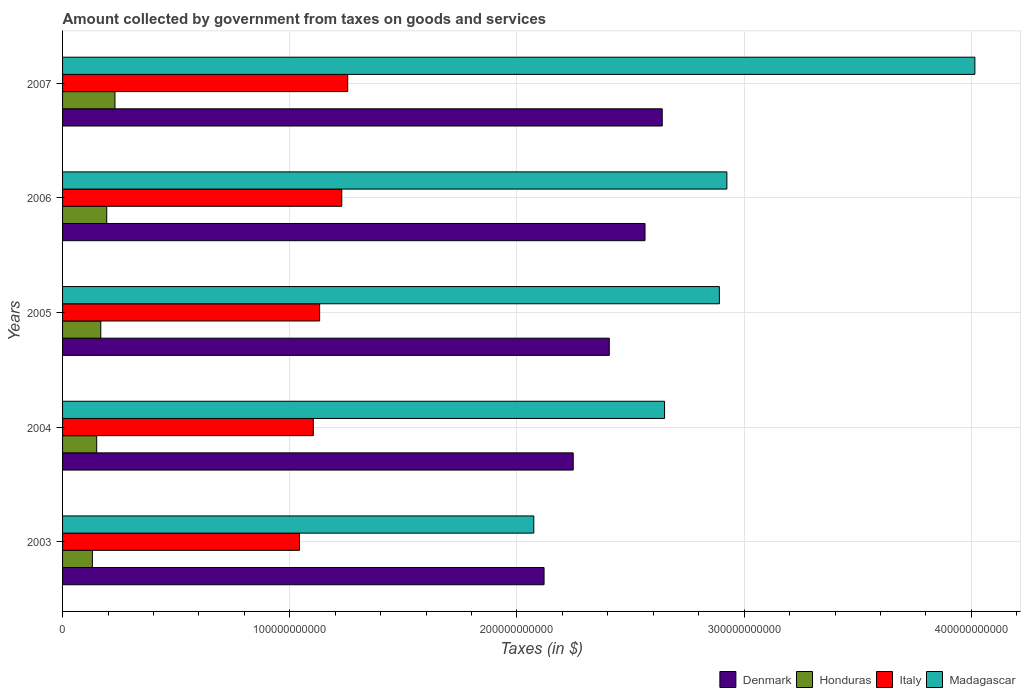How many different coloured bars are there?
Offer a very short reply. 4. How many groups of bars are there?
Ensure brevity in your answer.  5. How many bars are there on the 5th tick from the top?
Ensure brevity in your answer.  4. How many bars are there on the 1st tick from the bottom?
Your response must be concise. 4. In how many cases, is the number of bars for a given year not equal to the number of legend labels?
Ensure brevity in your answer.  0. What is the amount collected by government from taxes on goods and services in Honduras in 2003?
Give a very brief answer. 1.31e+1. Across all years, what is the maximum amount collected by government from taxes on goods and services in Madagascar?
Offer a very short reply. 4.02e+11. Across all years, what is the minimum amount collected by government from taxes on goods and services in Denmark?
Keep it short and to the point. 2.12e+11. In which year was the amount collected by government from taxes on goods and services in Madagascar maximum?
Offer a terse response. 2007. In which year was the amount collected by government from taxes on goods and services in Italy minimum?
Provide a succinct answer. 2003. What is the total amount collected by government from taxes on goods and services in Italy in the graph?
Provide a short and direct response. 5.76e+11. What is the difference between the amount collected by government from taxes on goods and services in Honduras in 2003 and that in 2006?
Keep it short and to the point. -6.32e+09. What is the difference between the amount collected by government from taxes on goods and services in Madagascar in 2006 and the amount collected by government from taxes on goods and services in Denmark in 2005?
Offer a terse response. 5.18e+1. What is the average amount collected by government from taxes on goods and services in Madagascar per year?
Offer a very short reply. 2.91e+11. In the year 2004, what is the difference between the amount collected by government from taxes on goods and services in Italy and amount collected by government from taxes on goods and services in Honduras?
Make the answer very short. 9.53e+1. In how many years, is the amount collected by government from taxes on goods and services in Madagascar greater than 340000000000 $?
Your response must be concise. 1. What is the ratio of the amount collected by government from taxes on goods and services in Honduras in 2006 to that in 2007?
Provide a succinct answer. 0.84. Is the difference between the amount collected by government from taxes on goods and services in Italy in 2003 and 2006 greater than the difference between the amount collected by government from taxes on goods and services in Honduras in 2003 and 2006?
Your response must be concise. No. What is the difference between the highest and the second highest amount collected by government from taxes on goods and services in Honduras?
Make the answer very short. 3.63e+09. What is the difference between the highest and the lowest amount collected by government from taxes on goods and services in Honduras?
Offer a very short reply. 9.94e+09. In how many years, is the amount collected by government from taxes on goods and services in Denmark greater than the average amount collected by government from taxes on goods and services in Denmark taken over all years?
Offer a terse response. 3. Is it the case that in every year, the sum of the amount collected by government from taxes on goods and services in Honduras and amount collected by government from taxes on goods and services in Denmark is greater than the sum of amount collected by government from taxes on goods and services in Madagascar and amount collected by government from taxes on goods and services in Italy?
Provide a succinct answer. Yes. What does the 1st bar from the top in 2003 represents?
Your answer should be compact. Madagascar. What does the 1st bar from the bottom in 2007 represents?
Offer a very short reply. Denmark. Are all the bars in the graph horizontal?
Keep it short and to the point. Yes. What is the difference between two consecutive major ticks on the X-axis?
Provide a succinct answer. 1.00e+11. Are the values on the major ticks of X-axis written in scientific E-notation?
Your answer should be very brief. No. Does the graph contain any zero values?
Provide a succinct answer. No. How are the legend labels stacked?
Keep it short and to the point. Horizontal. What is the title of the graph?
Keep it short and to the point. Amount collected by government from taxes on goods and services. Does "Samoa" appear as one of the legend labels in the graph?
Your answer should be compact. No. What is the label or title of the X-axis?
Your response must be concise. Taxes (in $). What is the label or title of the Y-axis?
Ensure brevity in your answer.  Years. What is the Taxes (in $) of Denmark in 2003?
Offer a very short reply. 2.12e+11. What is the Taxes (in $) in Honduras in 2003?
Ensure brevity in your answer.  1.31e+1. What is the Taxes (in $) in Italy in 2003?
Keep it short and to the point. 1.04e+11. What is the Taxes (in $) in Madagascar in 2003?
Your answer should be compact. 2.07e+11. What is the Taxes (in $) of Denmark in 2004?
Provide a short and direct response. 2.25e+11. What is the Taxes (in $) of Honduras in 2004?
Give a very brief answer. 1.50e+1. What is the Taxes (in $) in Italy in 2004?
Offer a very short reply. 1.10e+11. What is the Taxes (in $) in Madagascar in 2004?
Provide a succinct answer. 2.65e+11. What is the Taxes (in $) of Denmark in 2005?
Make the answer very short. 2.41e+11. What is the Taxes (in $) of Honduras in 2005?
Offer a very short reply. 1.68e+1. What is the Taxes (in $) of Italy in 2005?
Make the answer very short. 1.13e+11. What is the Taxes (in $) of Madagascar in 2005?
Offer a very short reply. 2.89e+11. What is the Taxes (in $) of Denmark in 2006?
Offer a very short reply. 2.56e+11. What is the Taxes (in $) in Honduras in 2006?
Your answer should be very brief. 1.94e+1. What is the Taxes (in $) in Italy in 2006?
Give a very brief answer. 1.23e+11. What is the Taxes (in $) of Madagascar in 2006?
Keep it short and to the point. 2.92e+11. What is the Taxes (in $) in Denmark in 2007?
Provide a succinct answer. 2.64e+11. What is the Taxes (in $) in Honduras in 2007?
Your response must be concise. 2.31e+1. What is the Taxes (in $) in Italy in 2007?
Ensure brevity in your answer.  1.26e+11. What is the Taxes (in $) in Madagascar in 2007?
Your answer should be compact. 4.02e+11. Across all years, what is the maximum Taxes (in $) of Denmark?
Offer a very short reply. 2.64e+11. Across all years, what is the maximum Taxes (in $) in Honduras?
Your response must be concise. 2.31e+1. Across all years, what is the maximum Taxes (in $) of Italy?
Give a very brief answer. 1.26e+11. Across all years, what is the maximum Taxes (in $) in Madagascar?
Provide a short and direct response. 4.02e+11. Across all years, what is the minimum Taxes (in $) of Denmark?
Provide a short and direct response. 2.12e+11. Across all years, what is the minimum Taxes (in $) in Honduras?
Provide a succinct answer. 1.31e+1. Across all years, what is the minimum Taxes (in $) of Italy?
Keep it short and to the point. 1.04e+11. Across all years, what is the minimum Taxes (in $) of Madagascar?
Provide a succinct answer. 2.07e+11. What is the total Taxes (in $) in Denmark in the graph?
Keep it short and to the point. 1.20e+12. What is the total Taxes (in $) of Honduras in the graph?
Keep it short and to the point. 8.75e+1. What is the total Taxes (in $) in Italy in the graph?
Make the answer very short. 5.76e+11. What is the total Taxes (in $) in Madagascar in the graph?
Offer a very short reply. 1.46e+12. What is the difference between the Taxes (in $) of Denmark in 2003 and that in 2004?
Provide a short and direct response. -1.28e+1. What is the difference between the Taxes (in $) in Honduras in 2003 and that in 2004?
Your answer should be very brief. -1.90e+09. What is the difference between the Taxes (in $) of Italy in 2003 and that in 2004?
Provide a succinct answer. -6.08e+09. What is the difference between the Taxes (in $) in Madagascar in 2003 and that in 2004?
Provide a succinct answer. -5.76e+1. What is the difference between the Taxes (in $) of Denmark in 2003 and that in 2005?
Your answer should be very brief. -2.87e+1. What is the difference between the Taxes (in $) in Honduras in 2003 and that in 2005?
Provide a succinct answer. -3.70e+09. What is the difference between the Taxes (in $) of Italy in 2003 and that in 2005?
Your response must be concise. -8.87e+09. What is the difference between the Taxes (in $) of Madagascar in 2003 and that in 2005?
Provide a short and direct response. -8.17e+1. What is the difference between the Taxes (in $) in Denmark in 2003 and that in 2006?
Give a very brief answer. -4.44e+1. What is the difference between the Taxes (in $) of Honduras in 2003 and that in 2006?
Provide a succinct answer. -6.32e+09. What is the difference between the Taxes (in $) in Italy in 2003 and that in 2006?
Keep it short and to the point. -1.86e+1. What is the difference between the Taxes (in $) of Madagascar in 2003 and that in 2006?
Offer a terse response. -8.50e+1. What is the difference between the Taxes (in $) in Denmark in 2003 and that in 2007?
Give a very brief answer. -5.20e+1. What is the difference between the Taxes (in $) in Honduras in 2003 and that in 2007?
Your answer should be compact. -9.94e+09. What is the difference between the Taxes (in $) in Italy in 2003 and that in 2007?
Give a very brief answer. -2.12e+1. What is the difference between the Taxes (in $) in Madagascar in 2003 and that in 2007?
Your answer should be compact. -1.94e+11. What is the difference between the Taxes (in $) of Denmark in 2004 and that in 2005?
Give a very brief answer. -1.59e+1. What is the difference between the Taxes (in $) of Honduras in 2004 and that in 2005?
Provide a short and direct response. -1.80e+09. What is the difference between the Taxes (in $) in Italy in 2004 and that in 2005?
Provide a succinct answer. -2.78e+09. What is the difference between the Taxes (in $) of Madagascar in 2004 and that in 2005?
Your answer should be compact. -2.41e+1. What is the difference between the Taxes (in $) in Denmark in 2004 and that in 2006?
Your answer should be compact. -3.16e+1. What is the difference between the Taxes (in $) in Honduras in 2004 and that in 2006?
Provide a short and direct response. -4.42e+09. What is the difference between the Taxes (in $) of Italy in 2004 and that in 2006?
Provide a short and direct response. -1.25e+1. What is the difference between the Taxes (in $) in Madagascar in 2004 and that in 2006?
Provide a succinct answer. -2.74e+1. What is the difference between the Taxes (in $) of Denmark in 2004 and that in 2007?
Give a very brief answer. -3.92e+1. What is the difference between the Taxes (in $) in Honduras in 2004 and that in 2007?
Your response must be concise. -8.05e+09. What is the difference between the Taxes (in $) of Italy in 2004 and that in 2007?
Ensure brevity in your answer.  -1.51e+1. What is the difference between the Taxes (in $) in Madagascar in 2004 and that in 2007?
Provide a short and direct response. -1.37e+11. What is the difference between the Taxes (in $) in Denmark in 2005 and that in 2006?
Keep it short and to the point. -1.57e+1. What is the difference between the Taxes (in $) in Honduras in 2005 and that in 2006?
Your answer should be very brief. -2.62e+09. What is the difference between the Taxes (in $) in Italy in 2005 and that in 2006?
Ensure brevity in your answer.  -9.75e+09. What is the difference between the Taxes (in $) of Madagascar in 2005 and that in 2006?
Offer a terse response. -3.30e+09. What is the difference between the Taxes (in $) of Denmark in 2005 and that in 2007?
Offer a very short reply. -2.33e+1. What is the difference between the Taxes (in $) in Honduras in 2005 and that in 2007?
Give a very brief answer. -6.25e+09. What is the difference between the Taxes (in $) in Italy in 2005 and that in 2007?
Your answer should be very brief. -1.24e+1. What is the difference between the Taxes (in $) of Madagascar in 2005 and that in 2007?
Offer a terse response. -1.12e+11. What is the difference between the Taxes (in $) of Denmark in 2006 and that in 2007?
Keep it short and to the point. -7.58e+09. What is the difference between the Taxes (in $) of Honduras in 2006 and that in 2007?
Ensure brevity in your answer.  -3.63e+09. What is the difference between the Taxes (in $) of Italy in 2006 and that in 2007?
Your answer should be very brief. -2.61e+09. What is the difference between the Taxes (in $) of Madagascar in 2006 and that in 2007?
Offer a very short reply. -1.09e+11. What is the difference between the Taxes (in $) in Denmark in 2003 and the Taxes (in $) in Honduras in 2004?
Make the answer very short. 1.97e+11. What is the difference between the Taxes (in $) of Denmark in 2003 and the Taxes (in $) of Italy in 2004?
Your answer should be very brief. 1.02e+11. What is the difference between the Taxes (in $) in Denmark in 2003 and the Taxes (in $) in Madagascar in 2004?
Your response must be concise. -5.30e+1. What is the difference between the Taxes (in $) of Honduras in 2003 and the Taxes (in $) of Italy in 2004?
Provide a short and direct response. -9.72e+1. What is the difference between the Taxes (in $) in Honduras in 2003 and the Taxes (in $) in Madagascar in 2004?
Give a very brief answer. -2.52e+11. What is the difference between the Taxes (in $) in Italy in 2003 and the Taxes (in $) in Madagascar in 2004?
Provide a short and direct response. -1.61e+11. What is the difference between the Taxes (in $) in Denmark in 2003 and the Taxes (in $) in Honduras in 2005?
Provide a succinct answer. 1.95e+11. What is the difference between the Taxes (in $) in Denmark in 2003 and the Taxes (in $) in Italy in 2005?
Give a very brief answer. 9.88e+1. What is the difference between the Taxes (in $) in Denmark in 2003 and the Taxes (in $) in Madagascar in 2005?
Ensure brevity in your answer.  -7.72e+1. What is the difference between the Taxes (in $) of Honduras in 2003 and the Taxes (in $) of Italy in 2005?
Keep it short and to the point. -1.00e+11. What is the difference between the Taxes (in $) in Honduras in 2003 and the Taxes (in $) in Madagascar in 2005?
Offer a very short reply. -2.76e+11. What is the difference between the Taxes (in $) of Italy in 2003 and the Taxes (in $) of Madagascar in 2005?
Your response must be concise. -1.85e+11. What is the difference between the Taxes (in $) in Denmark in 2003 and the Taxes (in $) in Honduras in 2006?
Provide a short and direct response. 1.92e+11. What is the difference between the Taxes (in $) in Denmark in 2003 and the Taxes (in $) in Italy in 2006?
Your answer should be very brief. 8.90e+1. What is the difference between the Taxes (in $) of Denmark in 2003 and the Taxes (in $) of Madagascar in 2006?
Offer a very short reply. -8.05e+1. What is the difference between the Taxes (in $) of Honduras in 2003 and the Taxes (in $) of Italy in 2006?
Your response must be concise. -1.10e+11. What is the difference between the Taxes (in $) in Honduras in 2003 and the Taxes (in $) in Madagascar in 2006?
Make the answer very short. -2.79e+11. What is the difference between the Taxes (in $) of Italy in 2003 and the Taxes (in $) of Madagascar in 2006?
Ensure brevity in your answer.  -1.88e+11. What is the difference between the Taxes (in $) of Denmark in 2003 and the Taxes (in $) of Honduras in 2007?
Make the answer very short. 1.89e+11. What is the difference between the Taxes (in $) of Denmark in 2003 and the Taxes (in $) of Italy in 2007?
Provide a succinct answer. 8.64e+1. What is the difference between the Taxes (in $) of Denmark in 2003 and the Taxes (in $) of Madagascar in 2007?
Offer a very short reply. -1.90e+11. What is the difference between the Taxes (in $) of Honduras in 2003 and the Taxes (in $) of Italy in 2007?
Make the answer very short. -1.12e+11. What is the difference between the Taxes (in $) of Honduras in 2003 and the Taxes (in $) of Madagascar in 2007?
Keep it short and to the point. -3.88e+11. What is the difference between the Taxes (in $) in Italy in 2003 and the Taxes (in $) in Madagascar in 2007?
Ensure brevity in your answer.  -2.97e+11. What is the difference between the Taxes (in $) in Denmark in 2004 and the Taxes (in $) in Honduras in 2005?
Your response must be concise. 2.08e+11. What is the difference between the Taxes (in $) of Denmark in 2004 and the Taxes (in $) of Italy in 2005?
Give a very brief answer. 1.12e+11. What is the difference between the Taxes (in $) in Denmark in 2004 and the Taxes (in $) in Madagascar in 2005?
Keep it short and to the point. -6.43e+1. What is the difference between the Taxes (in $) of Honduras in 2004 and the Taxes (in $) of Italy in 2005?
Offer a very short reply. -9.81e+1. What is the difference between the Taxes (in $) in Honduras in 2004 and the Taxes (in $) in Madagascar in 2005?
Provide a succinct answer. -2.74e+11. What is the difference between the Taxes (in $) in Italy in 2004 and the Taxes (in $) in Madagascar in 2005?
Your response must be concise. -1.79e+11. What is the difference between the Taxes (in $) of Denmark in 2004 and the Taxes (in $) of Honduras in 2006?
Provide a succinct answer. 2.05e+11. What is the difference between the Taxes (in $) in Denmark in 2004 and the Taxes (in $) in Italy in 2006?
Your response must be concise. 1.02e+11. What is the difference between the Taxes (in $) in Denmark in 2004 and the Taxes (in $) in Madagascar in 2006?
Your answer should be compact. -6.76e+1. What is the difference between the Taxes (in $) of Honduras in 2004 and the Taxes (in $) of Italy in 2006?
Your response must be concise. -1.08e+11. What is the difference between the Taxes (in $) of Honduras in 2004 and the Taxes (in $) of Madagascar in 2006?
Offer a very short reply. -2.77e+11. What is the difference between the Taxes (in $) in Italy in 2004 and the Taxes (in $) in Madagascar in 2006?
Give a very brief answer. -1.82e+11. What is the difference between the Taxes (in $) of Denmark in 2004 and the Taxes (in $) of Honduras in 2007?
Make the answer very short. 2.02e+11. What is the difference between the Taxes (in $) in Denmark in 2004 and the Taxes (in $) in Italy in 2007?
Provide a short and direct response. 9.93e+1. What is the difference between the Taxes (in $) in Denmark in 2004 and the Taxes (in $) in Madagascar in 2007?
Make the answer very short. -1.77e+11. What is the difference between the Taxes (in $) of Honduras in 2004 and the Taxes (in $) of Italy in 2007?
Your response must be concise. -1.10e+11. What is the difference between the Taxes (in $) in Honduras in 2004 and the Taxes (in $) in Madagascar in 2007?
Ensure brevity in your answer.  -3.87e+11. What is the difference between the Taxes (in $) in Italy in 2004 and the Taxes (in $) in Madagascar in 2007?
Ensure brevity in your answer.  -2.91e+11. What is the difference between the Taxes (in $) of Denmark in 2005 and the Taxes (in $) of Honduras in 2006?
Provide a short and direct response. 2.21e+11. What is the difference between the Taxes (in $) of Denmark in 2005 and the Taxes (in $) of Italy in 2006?
Offer a terse response. 1.18e+11. What is the difference between the Taxes (in $) of Denmark in 2005 and the Taxes (in $) of Madagascar in 2006?
Offer a terse response. -5.18e+1. What is the difference between the Taxes (in $) of Honduras in 2005 and the Taxes (in $) of Italy in 2006?
Ensure brevity in your answer.  -1.06e+11. What is the difference between the Taxes (in $) of Honduras in 2005 and the Taxes (in $) of Madagascar in 2006?
Provide a short and direct response. -2.76e+11. What is the difference between the Taxes (in $) of Italy in 2005 and the Taxes (in $) of Madagascar in 2006?
Keep it short and to the point. -1.79e+11. What is the difference between the Taxes (in $) of Denmark in 2005 and the Taxes (in $) of Honduras in 2007?
Give a very brief answer. 2.18e+11. What is the difference between the Taxes (in $) in Denmark in 2005 and the Taxes (in $) in Italy in 2007?
Keep it short and to the point. 1.15e+11. What is the difference between the Taxes (in $) in Denmark in 2005 and the Taxes (in $) in Madagascar in 2007?
Give a very brief answer. -1.61e+11. What is the difference between the Taxes (in $) of Honduras in 2005 and the Taxes (in $) of Italy in 2007?
Provide a short and direct response. -1.09e+11. What is the difference between the Taxes (in $) of Honduras in 2005 and the Taxes (in $) of Madagascar in 2007?
Your response must be concise. -3.85e+11. What is the difference between the Taxes (in $) of Italy in 2005 and the Taxes (in $) of Madagascar in 2007?
Your answer should be very brief. -2.88e+11. What is the difference between the Taxes (in $) of Denmark in 2006 and the Taxes (in $) of Honduras in 2007?
Your answer should be compact. 2.33e+11. What is the difference between the Taxes (in $) of Denmark in 2006 and the Taxes (in $) of Italy in 2007?
Provide a short and direct response. 1.31e+11. What is the difference between the Taxes (in $) of Denmark in 2006 and the Taxes (in $) of Madagascar in 2007?
Offer a very short reply. -1.45e+11. What is the difference between the Taxes (in $) in Honduras in 2006 and the Taxes (in $) in Italy in 2007?
Your answer should be compact. -1.06e+11. What is the difference between the Taxes (in $) in Honduras in 2006 and the Taxes (in $) in Madagascar in 2007?
Ensure brevity in your answer.  -3.82e+11. What is the difference between the Taxes (in $) of Italy in 2006 and the Taxes (in $) of Madagascar in 2007?
Make the answer very short. -2.79e+11. What is the average Taxes (in $) in Denmark per year?
Keep it short and to the point. 2.40e+11. What is the average Taxes (in $) of Honduras per year?
Provide a short and direct response. 1.75e+1. What is the average Taxes (in $) of Italy per year?
Keep it short and to the point. 1.15e+11. What is the average Taxes (in $) in Madagascar per year?
Give a very brief answer. 2.91e+11. In the year 2003, what is the difference between the Taxes (in $) in Denmark and Taxes (in $) in Honduras?
Offer a very short reply. 1.99e+11. In the year 2003, what is the difference between the Taxes (in $) in Denmark and Taxes (in $) in Italy?
Provide a succinct answer. 1.08e+11. In the year 2003, what is the difference between the Taxes (in $) in Denmark and Taxes (in $) in Madagascar?
Provide a succinct answer. 4.53e+09. In the year 2003, what is the difference between the Taxes (in $) in Honduras and Taxes (in $) in Italy?
Give a very brief answer. -9.12e+1. In the year 2003, what is the difference between the Taxes (in $) of Honduras and Taxes (in $) of Madagascar?
Offer a very short reply. -1.94e+11. In the year 2003, what is the difference between the Taxes (in $) in Italy and Taxes (in $) in Madagascar?
Keep it short and to the point. -1.03e+11. In the year 2004, what is the difference between the Taxes (in $) in Denmark and Taxes (in $) in Honduras?
Make the answer very short. 2.10e+11. In the year 2004, what is the difference between the Taxes (in $) of Denmark and Taxes (in $) of Italy?
Offer a terse response. 1.14e+11. In the year 2004, what is the difference between the Taxes (in $) in Denmark and Taxes (in $) in Madagascar?
Make the answer very short. -4.02e+1. In the year 2004, what is the difference between the Taxes (in $) of Honduras and Taxes (in $) of Italy?
Ensure brevity in your answer.  -9.53e+1. In the year 2004, what is the difference between the Taxes (in $) of Honduras and Taxes (in $) of Madagascar?
Your response must be concise. -2.50e+11. In the year 2004, what is the difference between the Taxes (in $) in Italy and Taxes (in $) in Madagascar?
Your answer should be very brief. -1.55e+11. In the year 2005, what is the difference between the Taxes (in $) of Denmark and Taxes (in $) of Honduras?
Your answer should be compact. 2.24e+11. In the year 2005, what is the difference between the Taxes (in $) in Denmark and Taxes (in $) in Italy?
Your answer should be very brief. 1.27e+11. In the year 2005, what is the difference between the Taxes (in $) of Denmark and Taxes (in $) of Madagascar?
Your answer should be compact. -4.85e+1. In the year 2005, what is the difference between the Taxes (in $) in Honduras and Taxes (in $) in Italy?
Ensure brevity in your answer.  -9.63e+1. In the year 2005, what is the difference between the Taxes (in $) of Honduras and Taxes (in $) of Madagascar?
Make the answer very short. -2.72e+11. In the year 2005, what is the difference between the Taxes (in $) of Italy and Taxes (in $) of Madagascar?
Provide a short and direct response. -1.76e+11. In the year 2006, what is the difference between the Taxes (in $) of Denmark and Taxes (in $) of Honduras?
Provide a succinct answer. 2.37e+11. In the year 2006, what is the difference between the Taxes (in $) of Denmark and Taxes (in $) of Italy?
Offer a very short reply. 1.33e+11. In the year 2006, what is the difference between the Taxes (in $) of Denmark and Taxes (in $) of Madagascar?
Make the answer very short. -3.60e+1. In the year 2006, what is the difference between the Taxes (in $) in Honduras and Taxes (in $) in Italy?
Provide a succinct answer. -1.03e+11. In the year 2006, what is the difference between the Taxes (in $) of Honduras and Taxes (in $) of Madagascar?
Provide a succinct answer. -2.73e+11. In the year 2006, what is the difference between the Taxes (in $) in Italy and Taxes (in $) in Madagascar?
Offer a very short reply. -1.70e+11. In the year 2007, what is the difference between the Taxes (in $) of Denmark and Taxes (in $) of Honduras?
Give a very brief answer. 2.41e+11. In the year 2007, what is the difference between the Taxes (in $) of Denmark and Taxes (in $) of Italy?
Provide a short and direct response. 1.38e+11. In the year 2007, what is the difference between the Taxes (in $) of Denmark and Taxes (in $) of Madagascar?
Offer a terse response. -1.38e+11. In the year 2007, what is the difference between the Taxes (in $) in Honduras and Taxes (in $) in Italy?
Provide a succinct answer. -1.02e+11. In the year 2007, what is the difference between the Taxes (in $) in Honduras and Taxes (in $) in Madagascar?
Offer a very short reply. -3.78e+11. In the year 2007, what is the difference between the Taxes (in $) of Italy and Taxes (in $) of Madagascar?
Give a very brief answer. -2.76e+11. What is the ratio of the Taxes (in $) in Denmark in 2003 to that in 2004?
Make the answer very short. 0.94. What is the ratio of the Taxes (in $) of Honduras in 2003 to that in 2004?
Your answer should be very brief. 0.87. What is the ratio of the Taxes (in $) of Italy in 2003 to that in 2004?
Offer a terse response. 0.94. What is the ratio of the Taxes (in $) in Madagascar in 2003 to that in 2004?
Make the answer very short. 0.78. What is the ratio of the Taxes (in $) of Denmark in 2003 to that in 2005?
Keep it short and to the point. 0.88. What is the ratio of the Taxes (in $) of Honduras in 2003 to that in 2005?
Make the answer very short. 0.78. What is the ratio of the Taxes (in $) of Italy in 2003 to that in 2005?
Your response must be concise. 0.92. What is the ratio of the Taxes (in $) in Madagascar in 2003 to that in 2005?
Your response must be concise. 0.72. What is the ratio of the Taxes (in $) of Denmark in 2003 to that in 2006?
Make the answer very short. 0.83. What is the ratio of the Taxes (in $) in Honduras in 2003 to that in 2006?
Your response must be concise. 0.68. What is the ratio of the Taxes (in $) in Italy in 2003 to that in 2006?
Give a very brief answer. 0.85. What is the ratio of the Taxes (in $) in Madagascar in 2003 to that in 2006?
Ensure brevity in your answer.  0.71. What is the ratio of the Taxes (in $) in Denmark in 2003 to that in 2007?
Provide a short and direct response. 0.8. What is the ratio of the Taxes (in $) in Honduras in 2003 to that in 2007?
Give a very brief answer. 0.57. What is the ratio of the Taxes (in $) of Italy in 2003 to that in 2007?
Make the answer very short. 0.83. What is the ratio of the Taxes (in $) in Madagascar in 2003 to that in 2007?
Keep it short and to the point. 0.52. What is the ratio of the Taxes (in $) of Denmark in 2004 to that in 2005?
Give a very brief answer. 0.93. What is the ratio of the Taxes (in $) in Honduras in 2004 to that in 2005?
Give a very brief answer. 0.89. What is the ratio of the Taxes (in $) of Italy in 2004 to that in 2005?
Make the answer very short. 0.98. What is the ratio of the Taxes (in $) in Madagascar in 2004 to that in 2005?
Your answer should be very brief. 0.92. What is the ratio of the Taxes (in $) of Denmark in 2004 to that in 2006?
Your answer should be compact. 0.88. What is the ratio of the Taxes (in $) in Honduras in 2004 to that in 2006?
Your answer should be compact. 0.77. What is the ratio of the Taxes (in $) in Italy in 2004 to that in 2006?
Give a very brief answer. 0.9. What is the ratio of the Taxes (in $) of Madagascar in 2004 to that in 2006?
Your answer should be very brief. 0.91. What is the ratio of the Taxes (in $) in Denmark in 2004 to that in 2007?
Provide a short and direct response. 0.85. What is the ratio of the Taxes (in $) in Honduras in 2004 to that in 2007?
Provide a succinct answer. 0.65. What is the ratio of the Taxes (in $) of Italy in 2004 to that in 2007?
Your response must be concise. 0.88. What is the ratio of the Taxes (in $) of Madagascar in 2004 to that in 2007?
Your answer should be compact. 0.66. What is the ratio of the Taxes (in $) in Denmark in 2005 to that in 2006?
Provide a short and direct response. 0.94. What is the ratio of the Taxes (in $) in Honduras in 2005 to that in 2006?
Keep it short and to the point. 0.87. What is the ratio of the Taxes (in $) of Italy in 2005 to that in 2006?
Your answer should be very brief. 0.92. What is the ratio of the Taxes (in $) of Madagascar in 2005 to that in 2006?
Keep it short and to the point. 0.99. What is the ratio of the Taxes (in $) in Denmark in 2005 to that in 2007?
Ensure brevity in your answer.  0.91. What is the ratio of the Taxes (in $) in Honduras in 2005 to that in 2007?
Your answer should be very brief. 0.73. What is the ratio of the Taxes (in $) in Italy in 2005 to that in 2007?
Keep it short and to the point. 0.9. What is the ratio of the Taxes (in $) of Madagascar in 2005 to that in 2007?
Keep it short and to the point. 0.72. What is the ratio of the Taxes (in $) in Denmark in 2006 to that in 2007?
Make the answer very short. 0.97. What is the ratio of the Taxes (in $) of Honduras in 2006 to that in 2007?
Your answer should be very brief. 0.84. What is the ratio of the Taxes (in $) in Italy in 2006 to that in 2007?
Give a very brief answer. 0.98. What is the ratio of the Taxes (in $) in Madagascar in 2006 to that in 2007?
Give a very brief answer. 0.73. What is the difference between the highest and the second highest Taxes (in $) in Denmark?
Your answer should be very brief. 7.58e+09. What is the difference between the highest and the second highest Taxes (in $) in Honduras?
Your answer should be very brief. 3.63e+09. What is the difference between the highest and the second highest Taxes (in $) of Italy?
Provide a short and direct response. 2.61e+09. What is the difference between the highest and the second highest Taxes (in $) of Madagascar?
Your answer should be compact. 1.09e+11. What is the difference between the highest and the lowest Taxes (in $) of Denmark?
Give a very brief answer. 5.20e+1. What is the difference between the highest and the lowest Taxes (in $) in Honduras?
Your answer should be very brief. 9.94e+09. What is the difference between the highest and the lowest Taxes (in $) in Italy?
Your answer should be very brief. 2.12e+1. What is the difference between the highest and the lowest Taxes (in $) of Madagascar?
Offer a very short reply. 1.94e+11. 